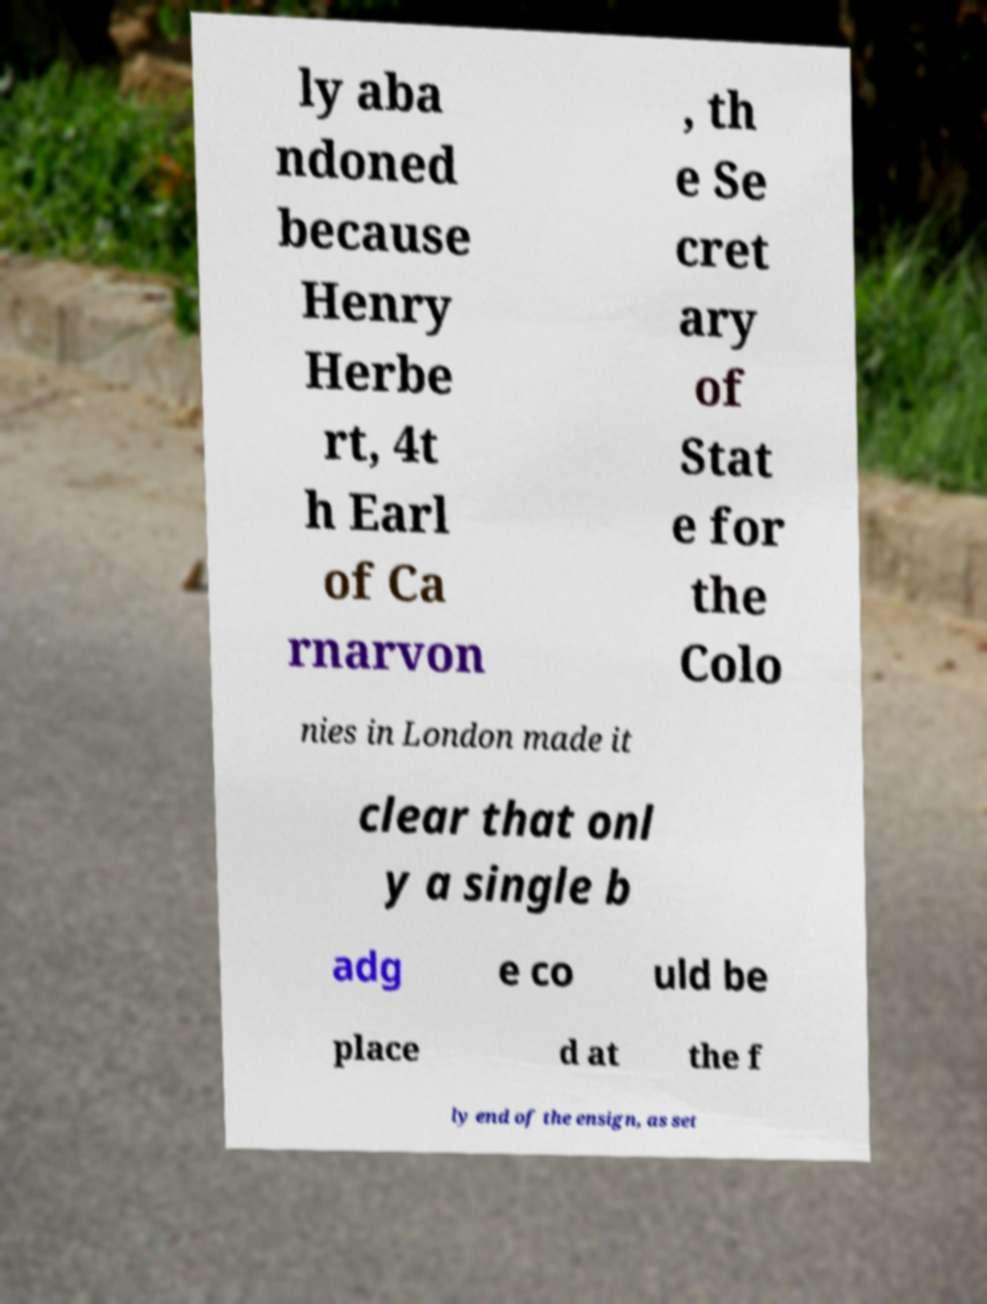Could you extract and type out the text from this image? ly aba ndoned because Henry Herbe rt, 4t h Earl of Ca rnarvon , th e Se cret ary of Stat e for the Colo nies in London made it clear that onl y a single b adg e co uld be place d at the f ly end of the ensign, as set 